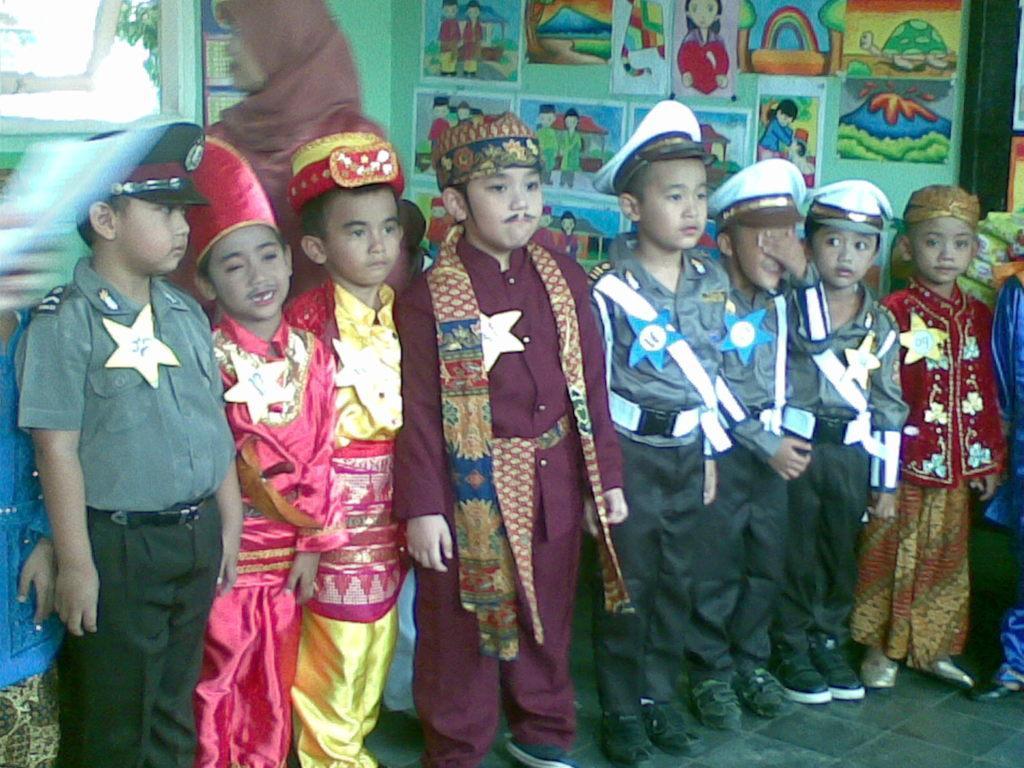In one or two sentences, can you explain what this image depicts? In the image we can see there are children's standing, wearing different costumes, shoes and caps. Here we can see the floor, wall and posters and drawings stick to the wall.  